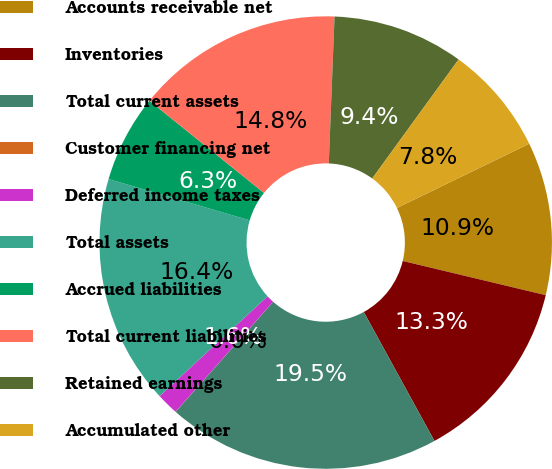Convert chart to OTSL. <chart><loc_0><loc_0><loc_500><loc_500><pie_chart><fcel>Accounts receivable net<fcel>Inventories<fcel>Total current assets<fcel>Customer financing net<fcel>Deferred income taxes<fcel>Total assets<fcel>Accrued liabilities<fcel>Total current liabilities<fcel>Retained earnings<fcel>Accumulated other<nl><fcel>10.93%<fcel>13.28%<fcel>19.52%<fcel>0.01%<fcel>1.57%<fcel>16.4%<fcel>6.25%<fcel>14.84%<fcel>9.37%<fcel>7.81%<nl></chart> 